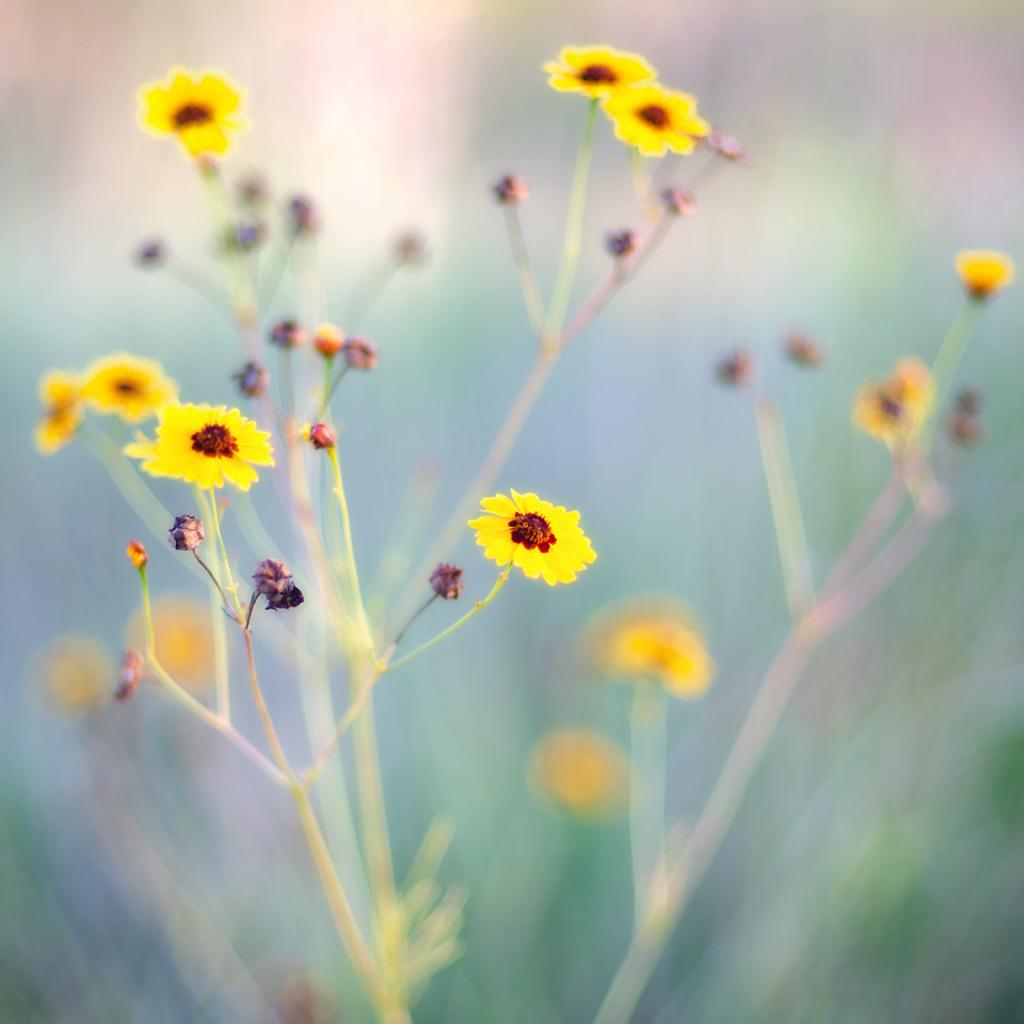What type of living organism can be seen in the image? There is a plant in the image. What color are the flowers on the plant? The plant has yellow flowers. Can you describe the background of the image? The background of the image is blurry. What type of quartz can be seen in the image? There is no quartz present in the image; it features a plant with yellow flowers. How many forks are visible in the image? There are no forks present in the image. 